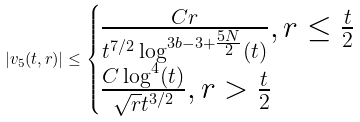Convert formula to latex. <formula><loc_0><loc_0><loc_500><loc_500>| v _ { 5 } ( t , r ) | \leq \begin{cases} \frac { C r } { t ^ { 7 / 2 } \log ^ { 3 b - 3 + \frac { 5 N } { 2 } } ( t ) } , r \leq \frac { t } { 2 } \\ \frac { C \log ^ { 4 } ( t ) } { \sqrt { r } t ^ { 3 / 2 } } , r > \frac { t } { 2 } \end{cases}</formula> 